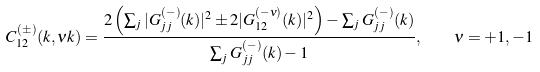Convert formula to latex. <formula><loc_0><loc_0><loc_500><loc_500>C _ { 1 2 } ^ { ( \pm ) } ( k , \nu k ) = \frac { 2 \left ( \sum _ { j } | G _ { j j } ^ { ( - ) } ( k ) | ^ { 2 } \pm 2 | G _ { 1 2 } ^ { ( - \nu ) } ( k ) | ^ { 2 } \right ) - \sum _ { j } G _ { j j } ^ { ( - ) } ( k ) } { \sum _ { j } G _ { j j } ^ { ( - ) } ( k ) - 1 } , \quad \nu = + 1 , - 1</formula> 